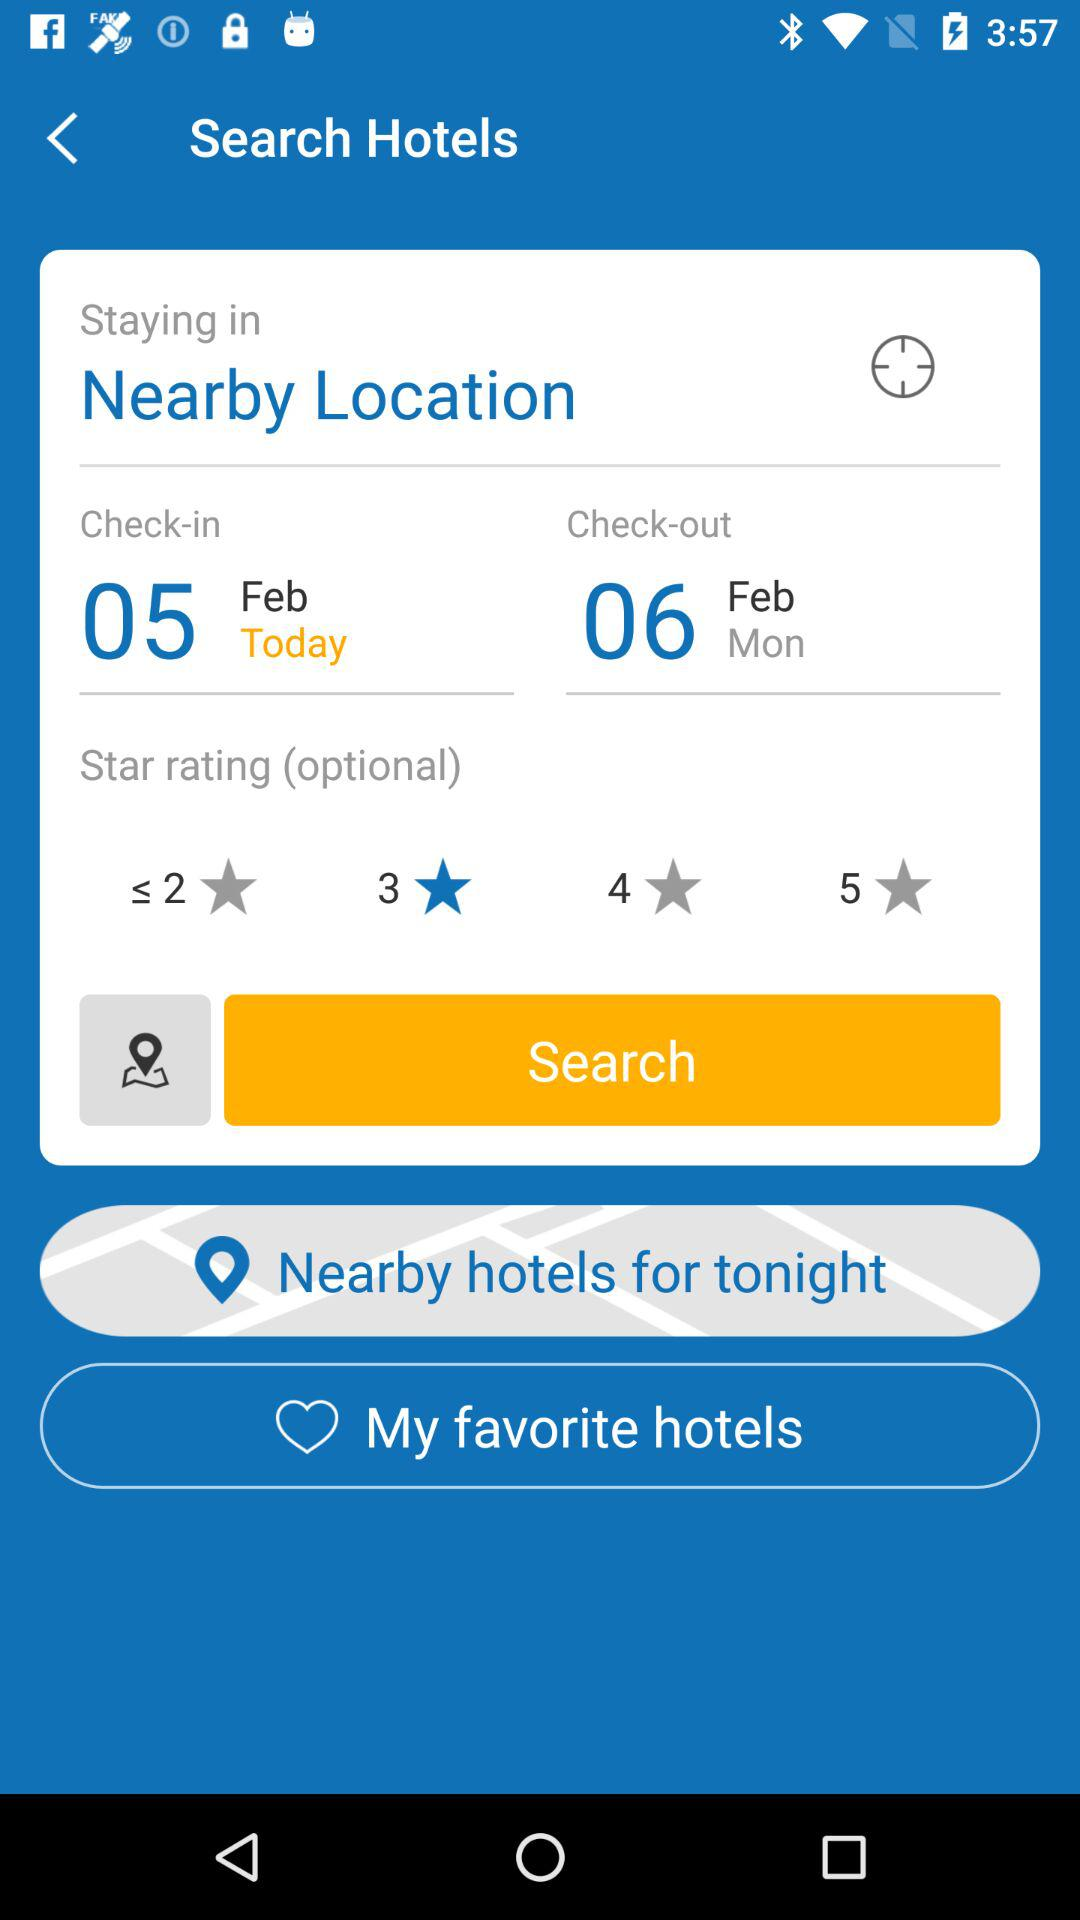Which star rating has been selected? The star rating that has been selected is 3. 